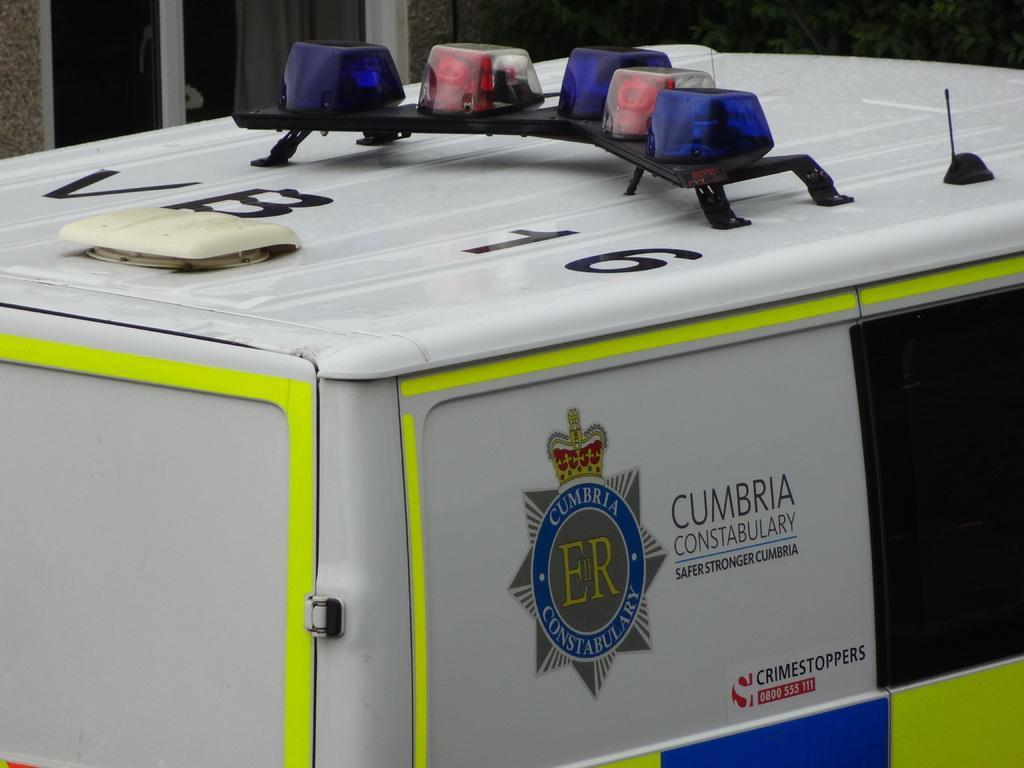Could you give a brief overview of what you see in this image? There are lights in different colors attached to the top surface of a vehicle. And this vehicle is white in color. 